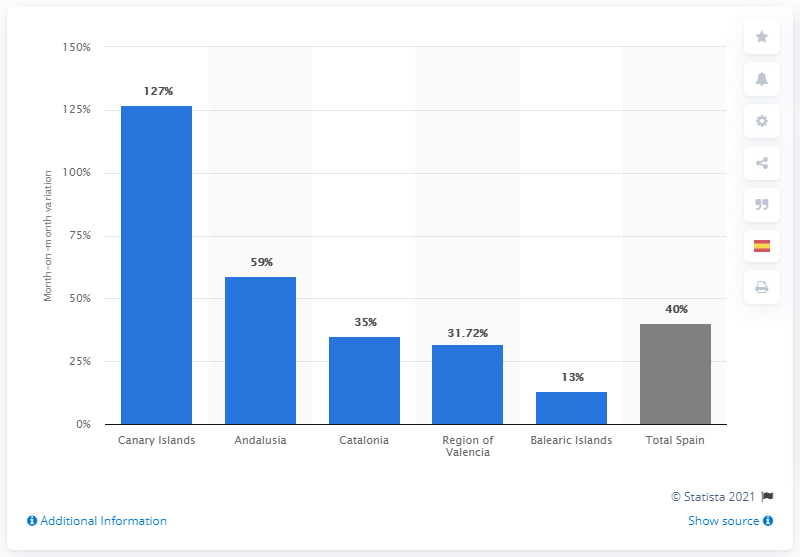Mention a couple of crucial points in this snapshot. The number of hotel reservation cancellations in the current month increased by 40 compared to the previous month. 